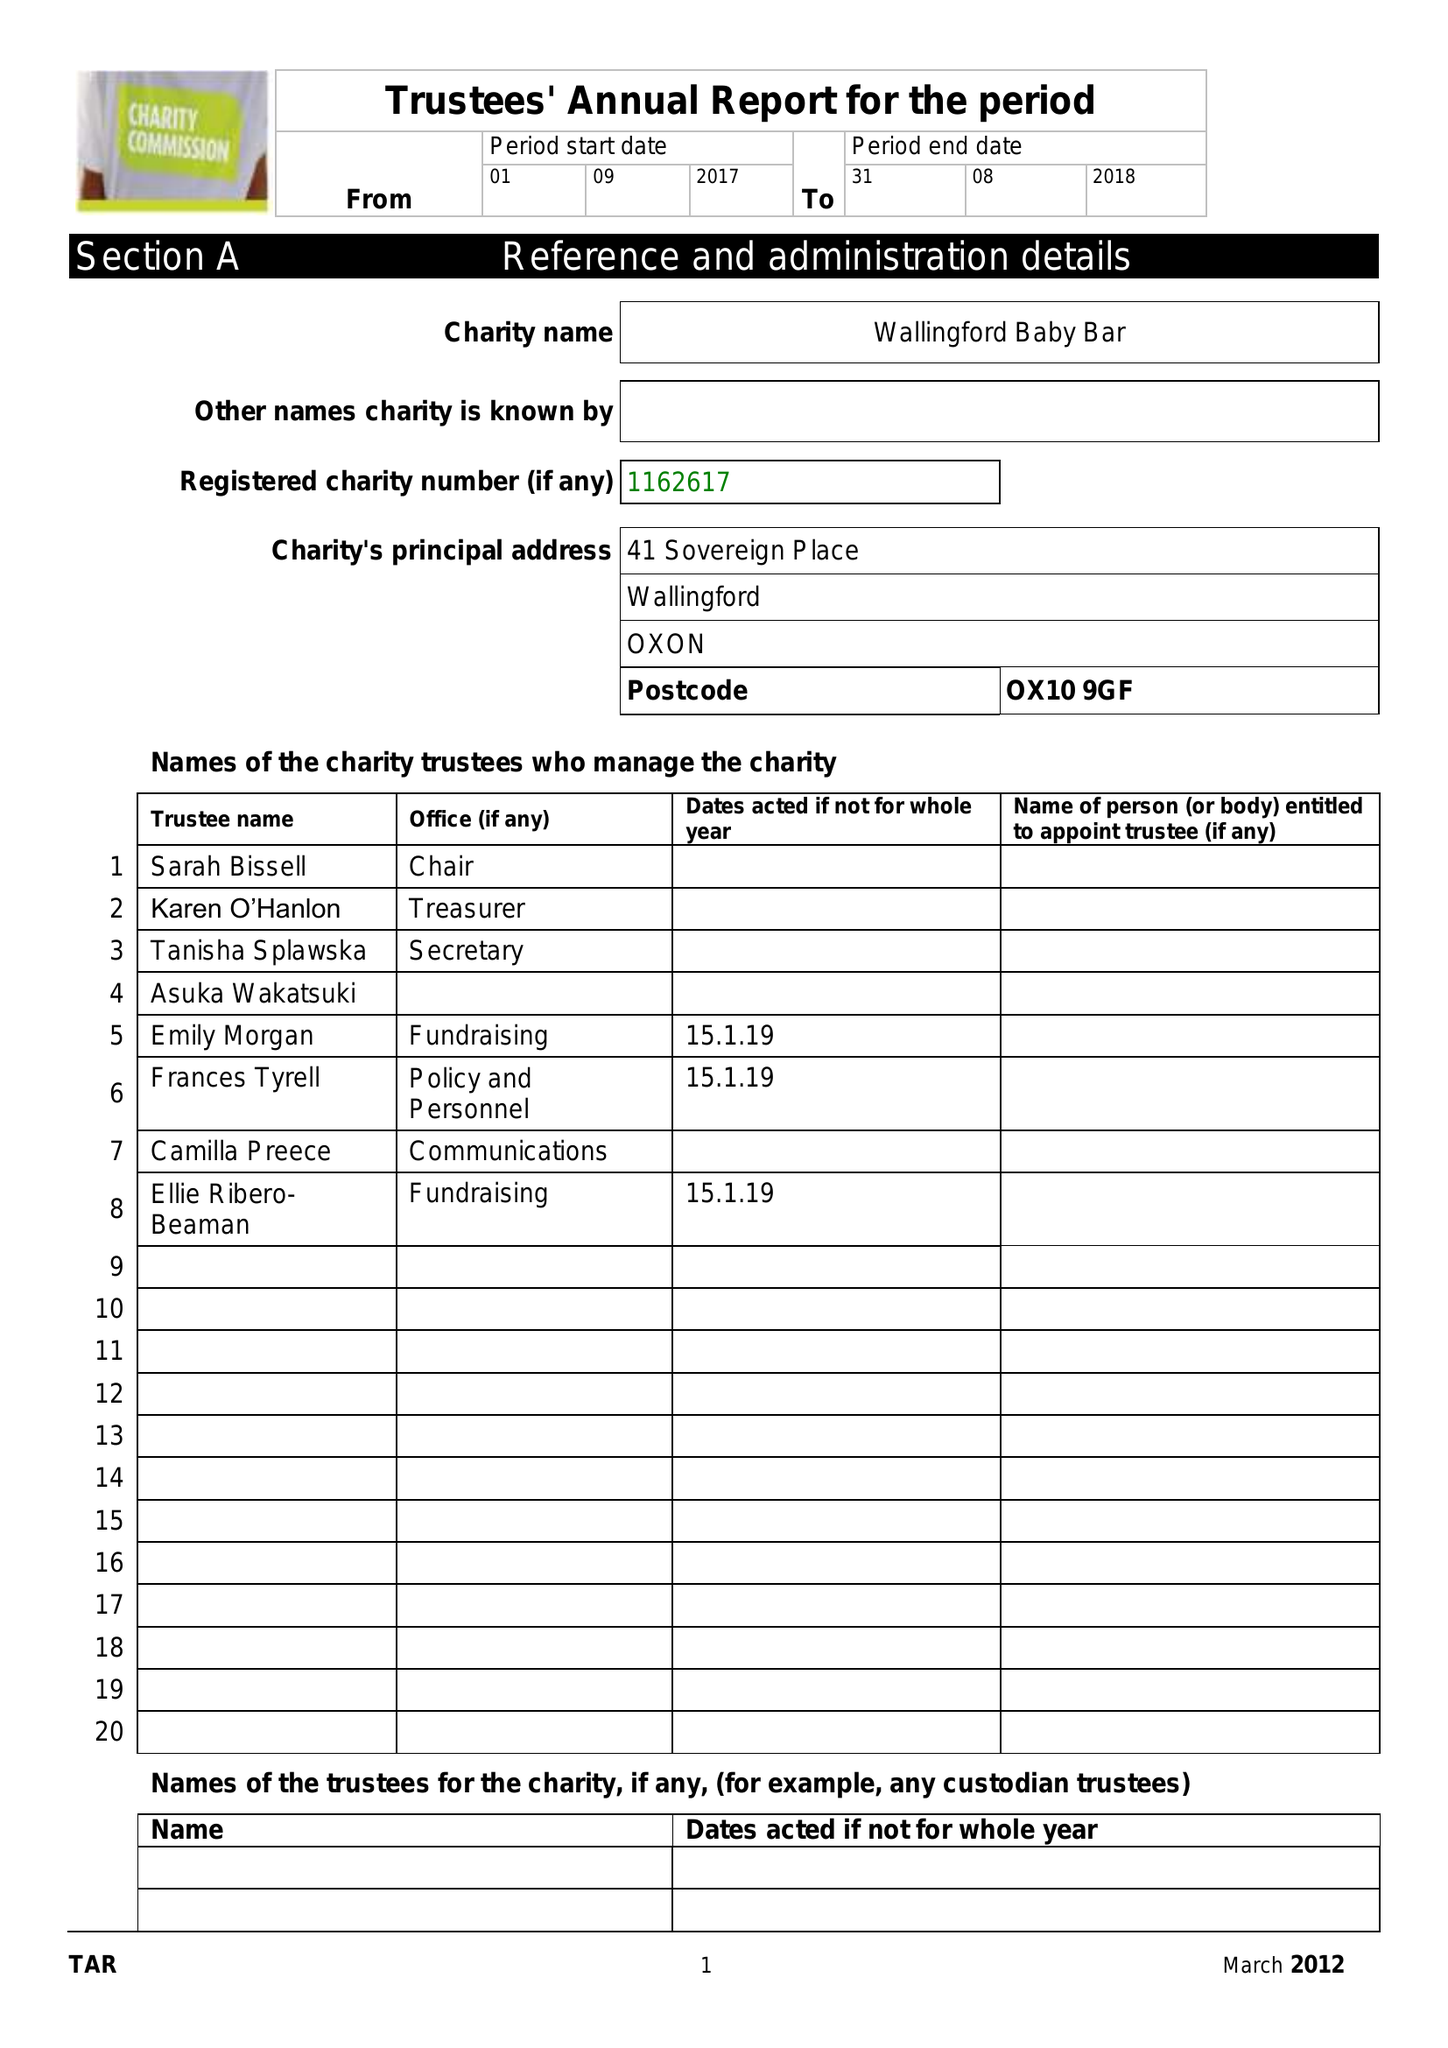What is the value for the address__street_line?
Answer the question using a single word or phrase. 41 SOVEREIGN PLACE 